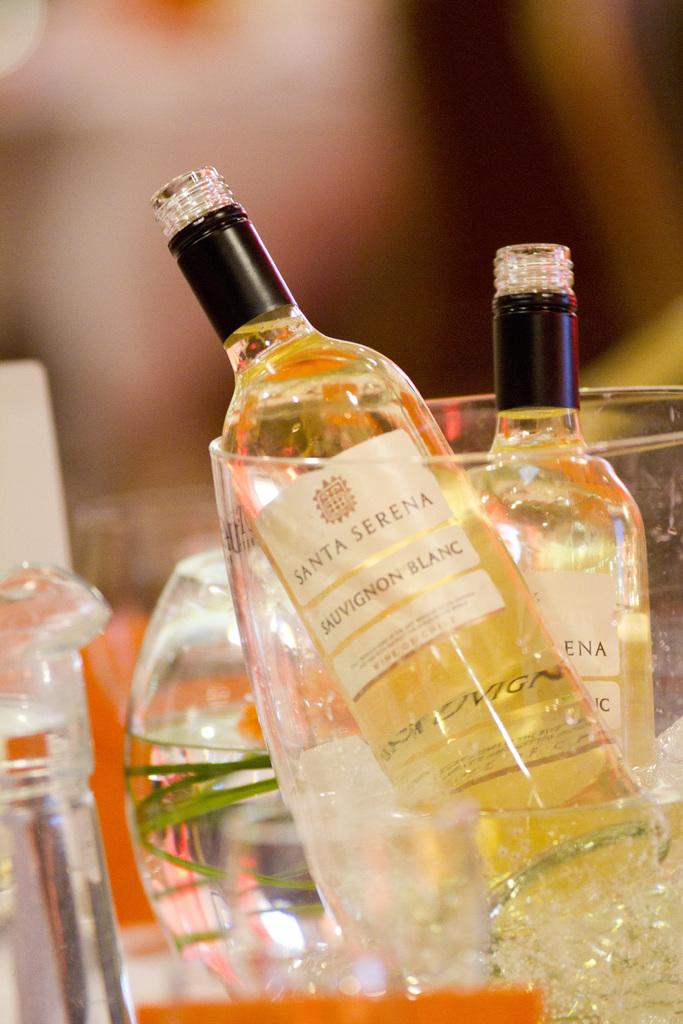Name of this wine?
Make the answer very short. Santa serena. What kind of wine?
Make the answer very short. Sauvignon blanc. 